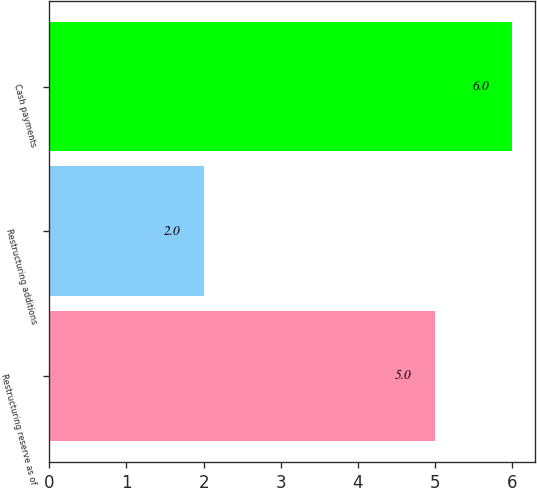<chart> <loc_0><loc_0><loc_500><loc_500><bar_chart><fcel>Restructuring reserve as of<fcel>Restructuring additions<fcel>Cash payments<nl><fcel>5<fcel>2<fcel>6<nl></chart> 